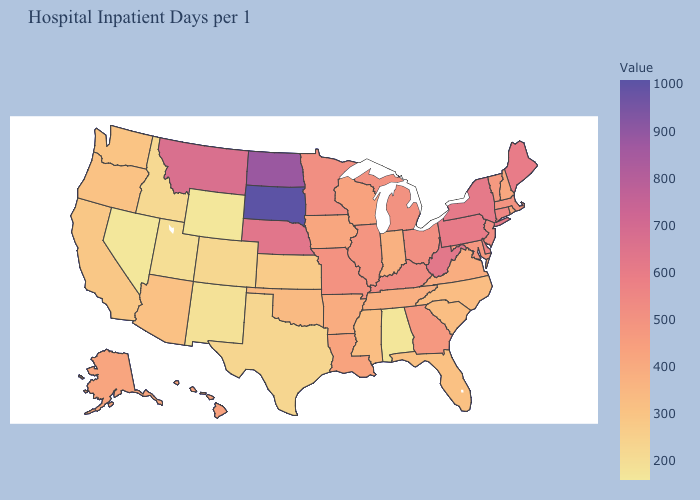Does South Carolina have the lowest value in the USA?
Concise answer only. No. Which states have the lowest value in the West?
Keep it brief. Nevada. Which states have the lowest value in the USA?
Write a very short answer. Nevada. Does Arizona have the lowest value in the USA?
Answer briefly. No. Among the states that border Arizona , which have the lowest value?
Give a very brief answer. Nevada. 